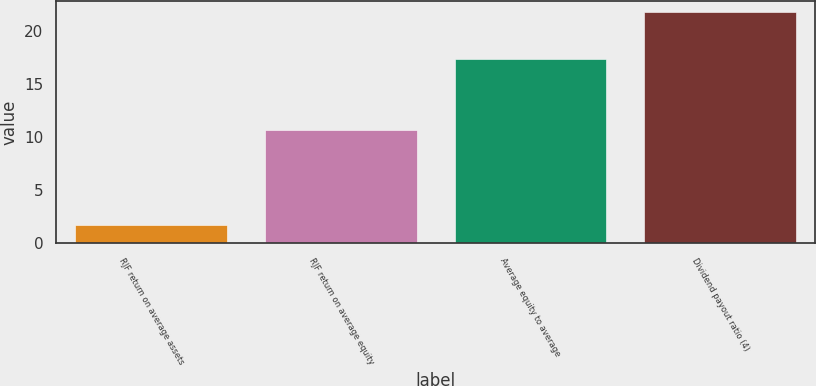Convert chart. <chart><loc_0><loc_0><loc_500><loc_500><bar_chart><fcel>RJF return on average assets<fcel>RJF return on average equity<fcel>Average equity to average<fcel>Dividend payout ratio (4)<nl><fcel>1.7<fcel>10.6<fcel>17.3<fcel>21.7<nl></chart> 